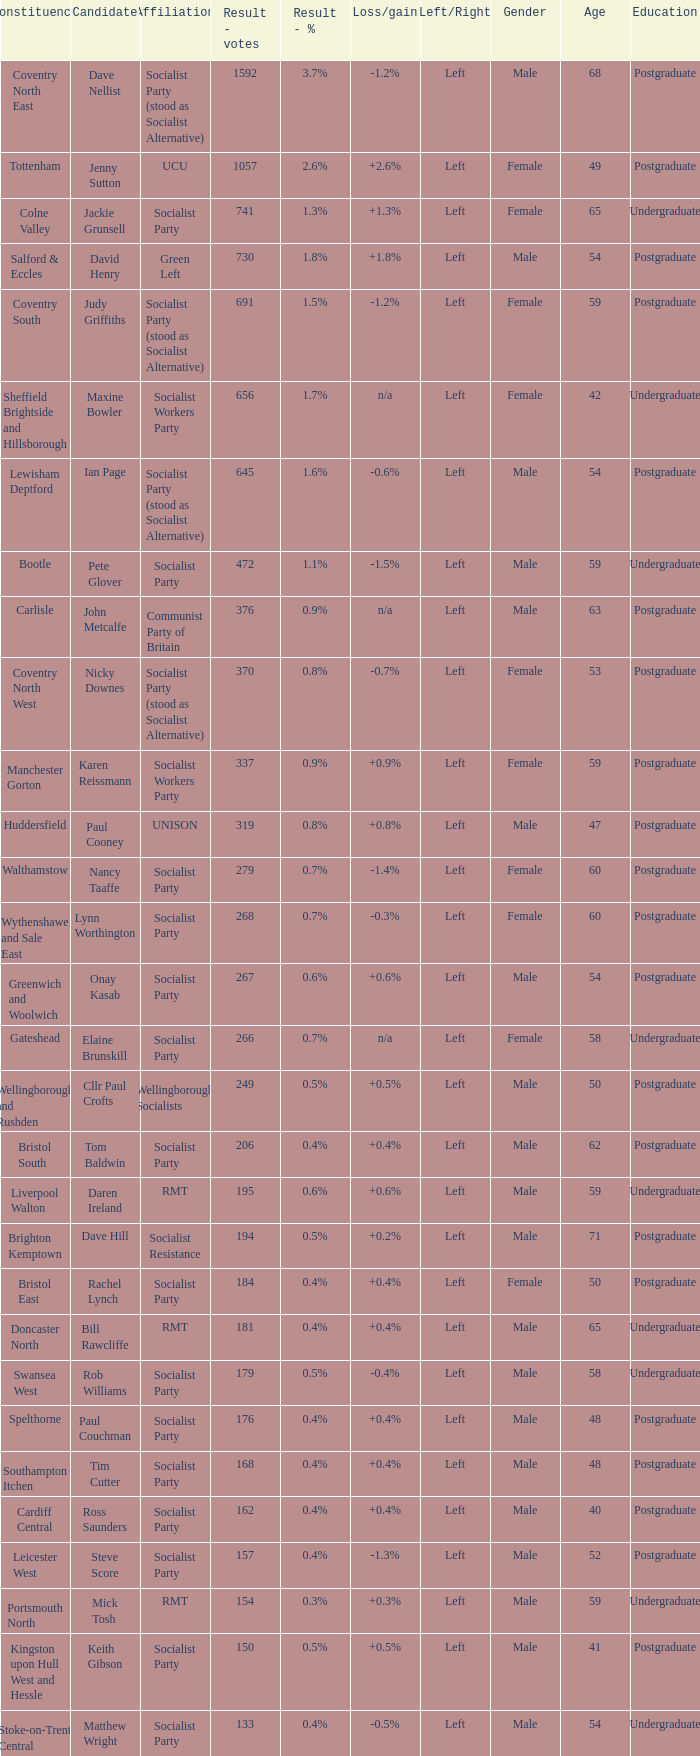What is every affiliation for the Tottenham constituency? UCU. 